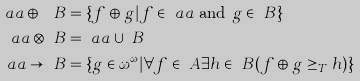<formula> <loc_0><loc_0><loc_500><loc_500>\ a a \oplus \ B & = \{ f \oplus g | f \in \ a a \text { and } g \in \ B \} \\ \ a a \otimes \ B & = \ a a \cup \ B \\ \ a a \to \ B & = \{ g \in \omega ^ { \omega } | \forall f \in \ A \exists h \in \ B ( f \oplus g \geq _ { T } h ) \}</formula> 